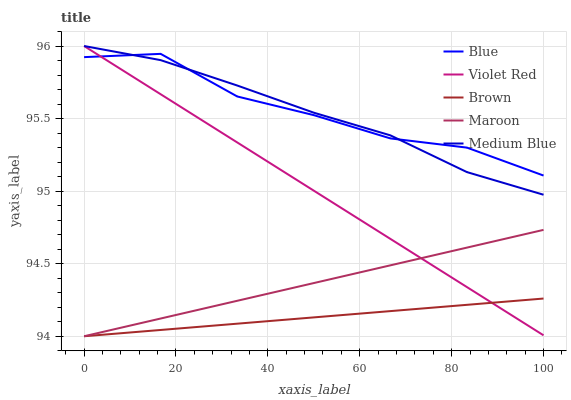Does Brown have the minimum area under the curve?
Answer yes or no. Yes. Does Blue have the maximum area under the curve?
Answer yes or no. Yes. Does Violet Red have the minimum area under the curve?
Answer yes or no. No. Does Violet Red have the maximum area under the curve?
Answer yes or no. No. Is Brown the smoothest?
Answer yes or no. Yes. Is Blue the roughest?
Answer yes or no. Yes. Is Violet Red the smoothest?
Answer yes or no. No. Is Violet Red the roughest?
Answer yes or no. No. Does Brown have the lowest value?
Answer yes or no. Yes. Does Violet Red have the lowest value?
Answer yes or no. No. Does Medium Blue have the highest value?
Answer yes or no. Yes. Does Brown have the highest value?
Answer yes or no. No. Is Maroon less than Medium Blue?
Answer yes or no. Yes. Is Medium Blue greater than Maroon?
Answer yes or no. Yes. Does Violet Red intersect Maroon?
Answer yes or no. Yes. Is Violet Red less than Maroon?
Answer yes or no. No. Is Violet Red greater than Maroon?
Answer yes or no. No. Does Maroon intersect Medium Blue?
Answer yes or no. No. 